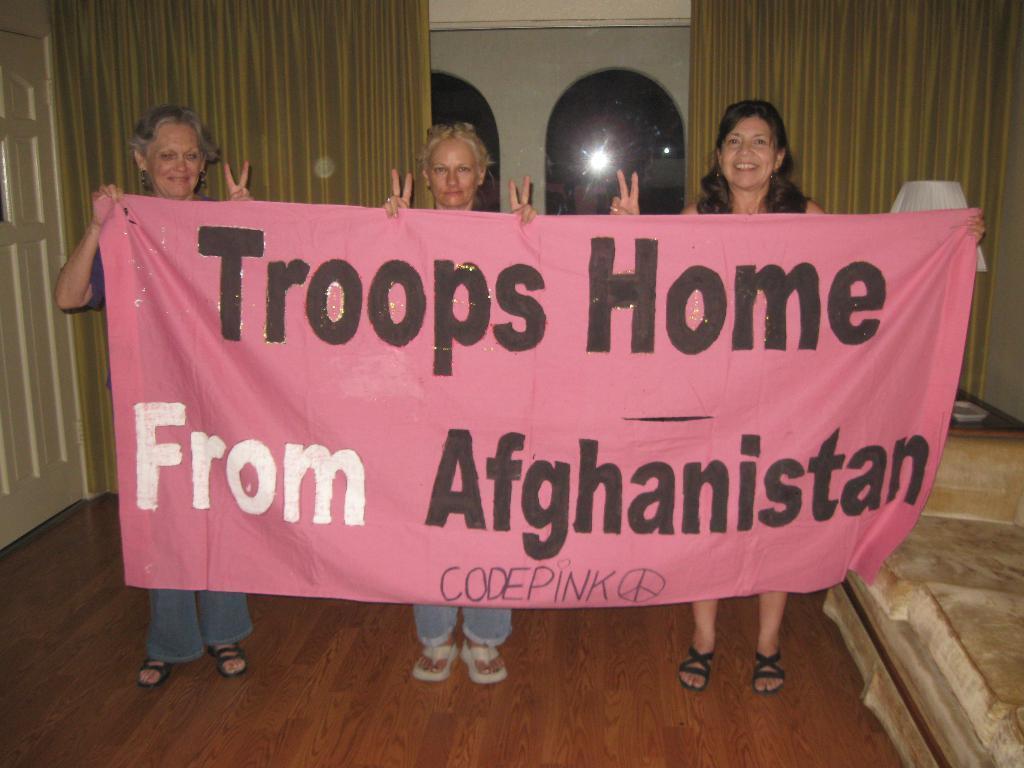Please provide a concise description of this image. Here we can see three women standing on the floor and holding a banner in their hands. In the background we can see a door,wall,curtains,window,lamp on a platform and this is a wall. 